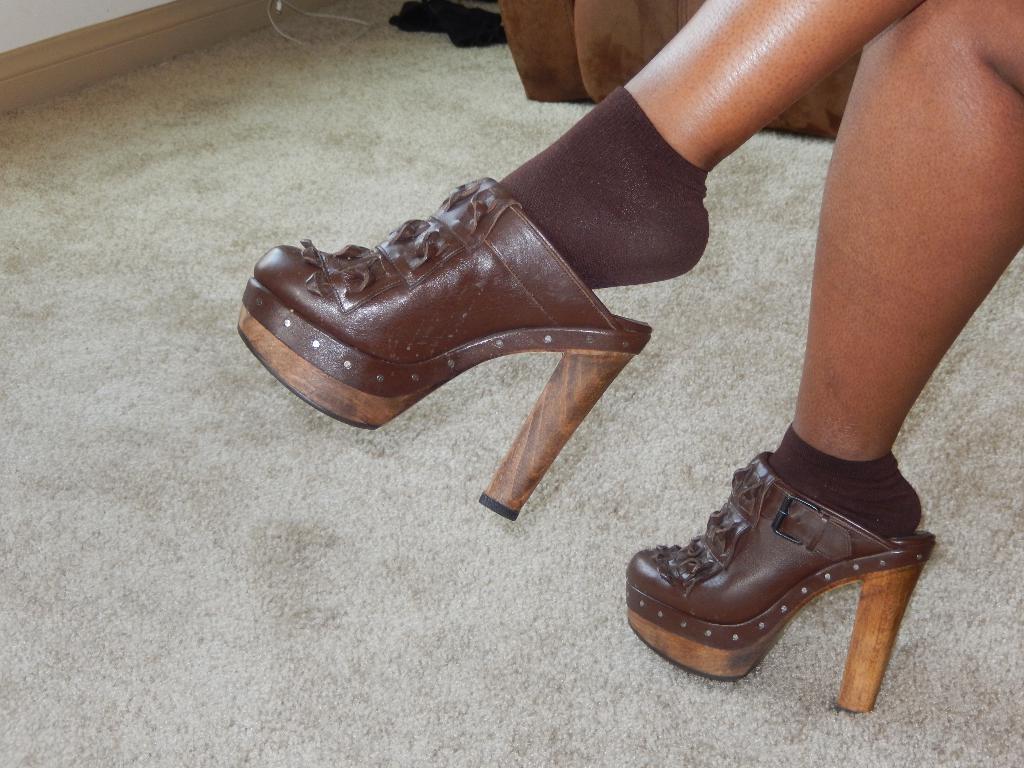Could you give a brief overview of what you see in this image? In this picture we can see legs of a human wearing a brown socks and brown colour foot wear. This is a floor carpet. This is a wire. Here we can see black cloth. 